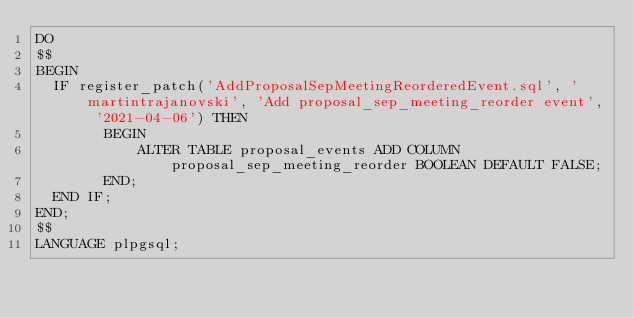<code> <loc_0><loc_0><loc_500><loc_500><_SQL_>DO
$$
BEGIN
	IF register_patch('AddProposalSepMeetingReorderedEvent.sql', 'martintrajanovski', 'Add proposal_sep_meeting_reorder event', '2021-04-06') THEN
        BEGIN
            ALTER TABLE proposal_events ADD COLUMN proposal_sep_meeting_reorder BOOLEAN DEFAULT FALSE;
        END;
	END IF;
END;
$$
LANGUAGE plpgsql;</code> 